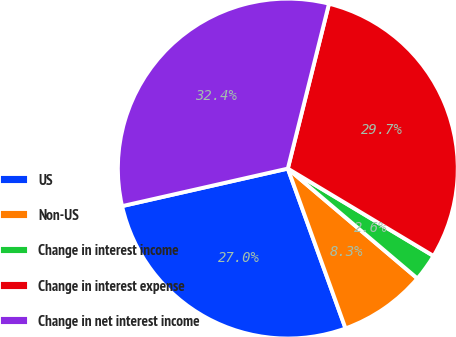<chart> <loc_0><loc_0><loc_500><loc_500><pie_chart><fcel>US<fcel>Non-US<fcel>Change in interest income<fcel>Change in interest expense<fcel>Change in net interest income<nl><fcel>26.97%<fcel>8.29%<fcel>2.6%<fcel>29.7%<fcel>32.44%<nl></chart> 